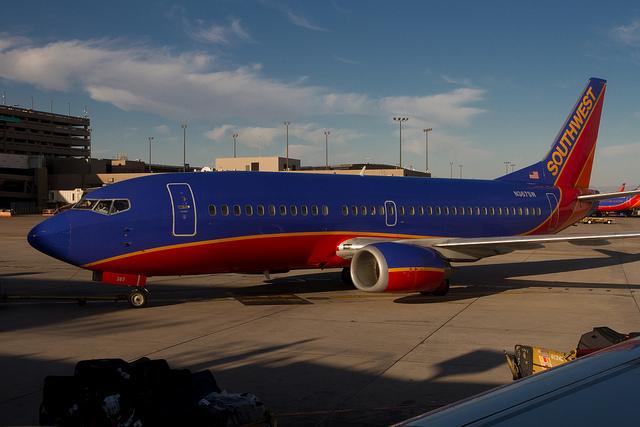Is this at an airport?
Write a very short answer. Yes. What two colors is this jet?
Concise answer only. Blue and red. What color is the plane?
Short answer required. Blue and red. Who took the picture?
Concise answer only. Person. What company fly's this plane?
Concise answer only. Southwest. What's colors are the plane?
Quick response, please. Blue and red. 